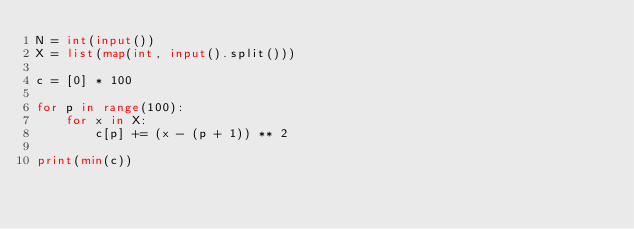Convert code to text. <code><loc_0><loc_0><loc_500><loc_500><_Python_>N = int(input())
X = list(map(int, input().split()))

c = [0] * 100

for p in range(100):
    for x in X:
        c[p] += (x - (p + 1)) ** 2

print(min(c))
</code> 